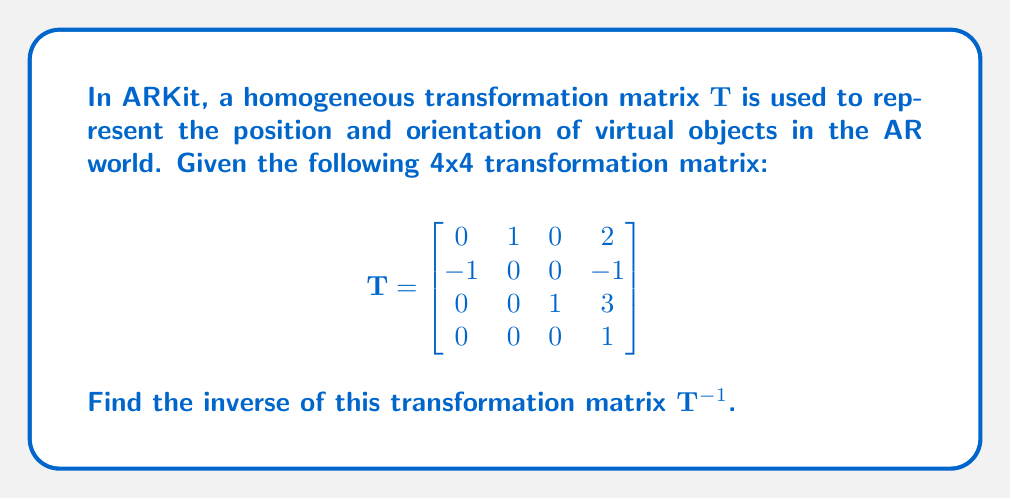Help me with this question. To find the inverse of a homogeneous transformation matrix, we can use the special structure of these matrices. A homogeneous transformation matrix $\mathbf{T}$ can be written as:

$$\mathbf{T} = \begin{bmatrix}
\mathbf{R} & \mathbf{t} \\
\mathbf{0}^T & 1
\end{bmatrix}$$

Where $\mathbf{R}$ is a 3x3 rotation matrix and $\mathbf{t}$ is a 3x1 translation vector.

The inverse of $\mathbf{T}$ is given by:

$$\mathbf{T}^{-1} = \begin{bmatrix}
\mathbf{R}^T & -\mathbf{R}^T\mathbf{t} \\
\mathbf{0}^T & 1
\end{bmatrix}$$

For our given matrix:

$$\mathbf{R} = \begin{bmatrix}
0 & 1 & 0 \\
-1 & 0 & 0 \\
0 & 0 & 1
\end{bmatrix}, \quad \mathbf{t} = \begin{bmatrix}
2 \\ -1 \\ 3
\end{bmatrix}$$

Step 1: Calculate $\mathbf{R}^T$
$$\mathbf{R}^T = \begin{bmatrix}
0 & -1 & 0 \\
1 & 0 & 0 \\
0 & 0 & 1
\end{bmatrix}$$

Step 2: Calculate $-\mathbf{R}^T\mathbf{t}$
$$-\mathbf{R}^T\mathbf{t} = -\begin{bmatrix}
0 & -1 & 0 \\
1 & 0 & 0 \\
0 & 0 & 1
\end{bmatrix}\begin{bmatrix}
2 \\ -1 \\ 3
\end{bmatrix} = \begin{bmatrix}
1 \\ -2 \\ -3
\end{bmatrix}$$

Step 3: Assemble the inverse matrix
$$\mathbf{T}^{-1} = \begin{bmatrix}
0 & -1 & 0 & 1 \\
1 & 0 & 0 & -2 \\
0 & 0 & 1 & -3 \\
0 & 0 & 0 & 1
\end{bmatrix}$$
Answer: $$\mathbf{T}^{-1} = \begin{bmatrix}
0 & -1 & 0 & 1 \\
1 & 0 & 0 & -2 \\
0 & 0 & 1 & -3 \\
0 & 0 & 0 & 1
\end{bmatrix}$$ 